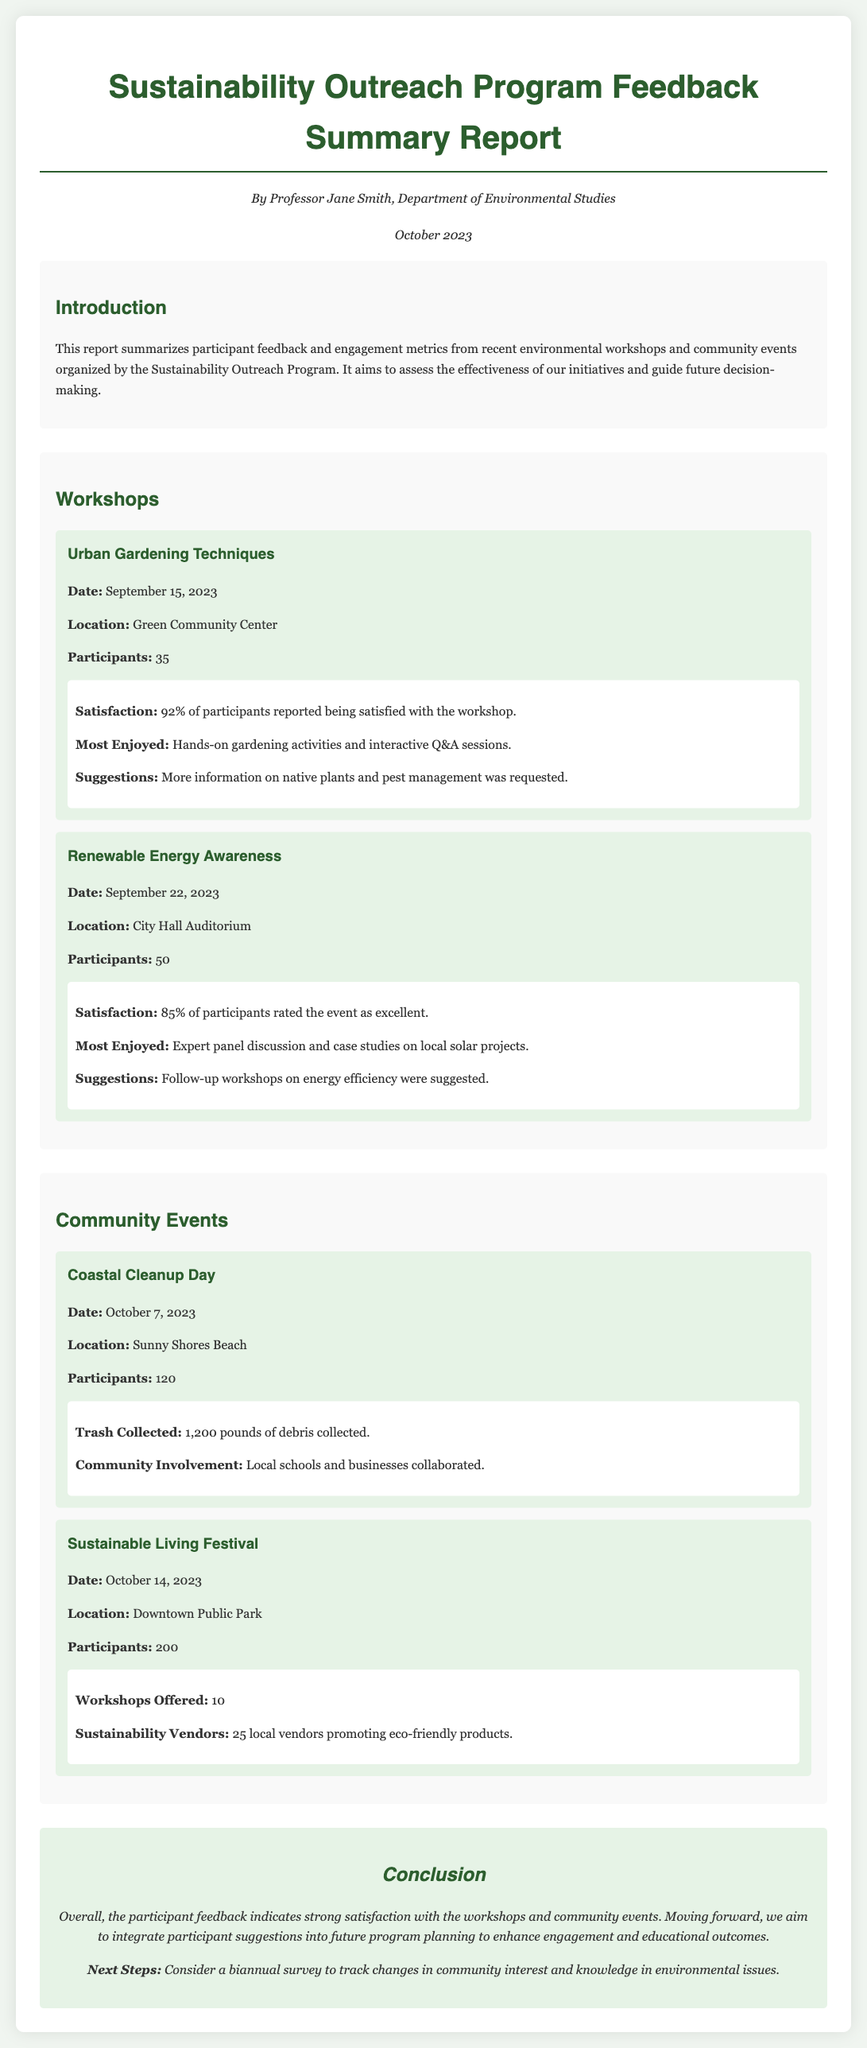What was the date of the Urban Gardening Techniques workshop? The date is provided in the event details of the Urban Gardening Techniques workshop.
Answer: September 15, 2023 How many participants attended the Renewable Energy Awareness event? The number of participants is mentioned as part of the event details for Renewable Energy Awareness.
Answer: 50 What percentage of participants felt satisfied with the Urban Gardening Techniques workshop? This information is found in the feedback section for the Urban Gardening Techniques workshop.
Answer: 92% What was the location of the Coastal Cleanup Day? The location is stated in the event details for the Coastal Cleanup Day.
Answer: Sunny Shores Beach How many pounds of debris were collected during the Coastal Cleanup Day? The total trash collected is given in the metrics section of the Coastal Cleanup Day event.
Answer: 1,200 pounds Which event had the highest number of participants? The comparison can be derived from the number of participants listed under each event.
Answer: Sustainable Living Festival What was one suggestion made by participants of the Renewable Energy Awareness event? Suggestions from participants are noted in the feedback for the Renewable Energy Awareness workshop.
Answer: Follow-up workshops on energy efficiency How many local vendors participated in the Sustainable Living Festival? The number of vendors is specified in the metrics section for the Sustainable Living Festival.
Answer: 25 local vendors What is the main conclusion drawn from the participant feedback? The conclusion summarizes the overall feedback collected in the report.
Answer: Strong satisfaction with the workshops and community events 